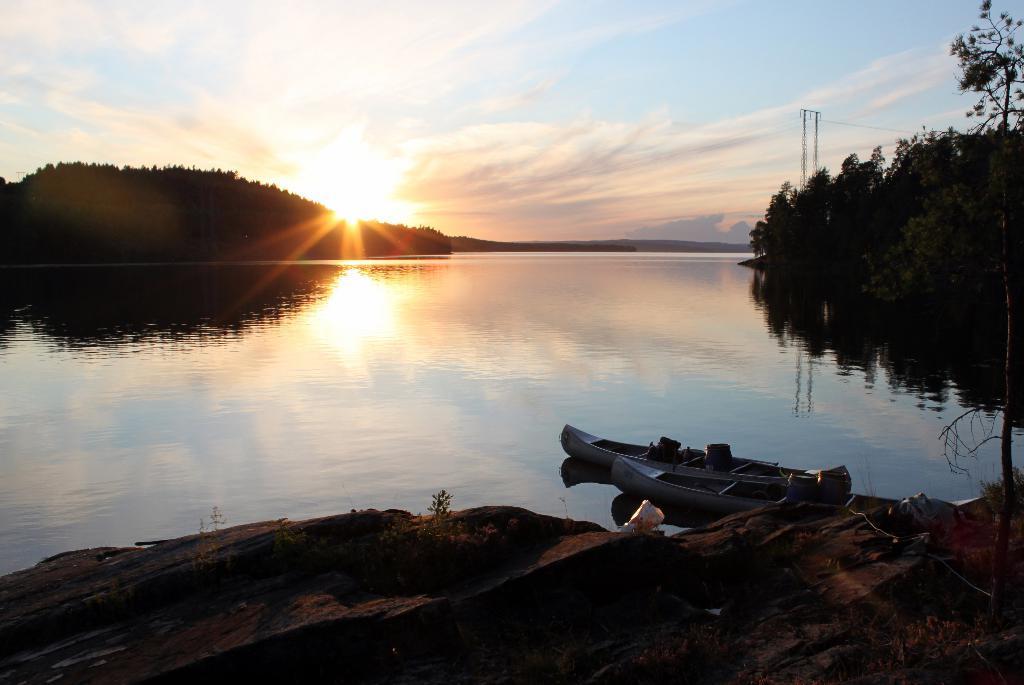Could you give a brief overview of what you see in this image? In this image there is water. There are stones and mud. There are boats. On the right side there are trees. On the left side background also there are trees. There is a sky. 